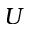<formula> <loc_0><loc_0><loc_500><loc_500>U</formula> 